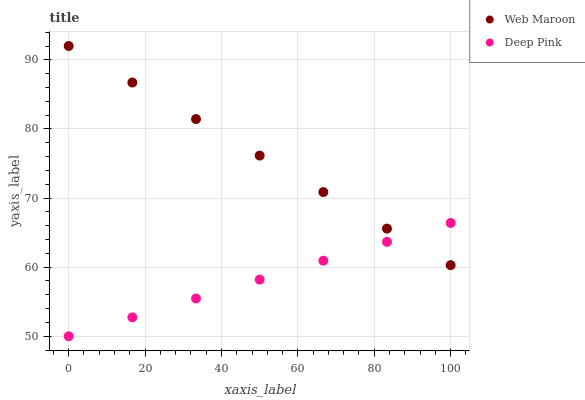Does Deep Pink have the minimum area under the curve?
Answer yes or no. Yes. Does Web Maroon have the maximum area under the curve?
Answer yes or no. Yes. Does Web Maroon have the minimum area under the curve?
Answer yes or no. No. Is Web Maroon the smoothest?
Answer yes or no. Yes. Is Deep Pink the roughest?
Answer yes or no. Yes. Is Web Maroon the roughest?
Answer yes or no. No. Does Deep Pink have the lowest value?
Answer yes or no. Yes. Does Web Maroon have the lowest value?
Answer yes or no. No. Does Web Maroon have the highest value?
Answer yes or no. Yes. Does Deep Pink intersect Web Maroon?
Answer yes or no. Yes. Is Deep Pink less than Web Maroon?
Answer yes or no. No. Is Deep Pink greater than Web Maroon?
Answer yes or no. No. 